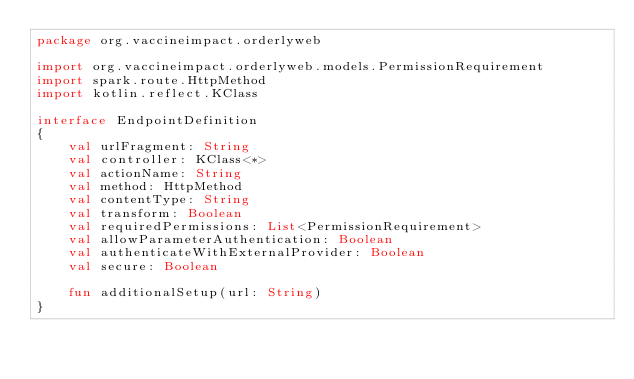<code> <loc_0><loc_0><loc_500><loc_500><_Kotlin_>package org.vaccineimpact.orderlyweb

import org.vaccineimpact.orderlyweb.models.PermissionRequirement
import spark.route.HttpMethod
import kotlin.reflect.KClass

interface EndpointDefinition
{
    val urlFragment: String
    val controller: KClass<*>
    val actionName: String
    val method: HttpMethod
    val contentType: String
    val transform: Boolean
    val requiredPermissions: List<PermissionRequirement>
    val allowParameterAuthentication: Boolean
    val authenticateWithExternalProvider: Boolean
    val secure: Boolean

    fun additionalSetup(url: String)
}</code> 